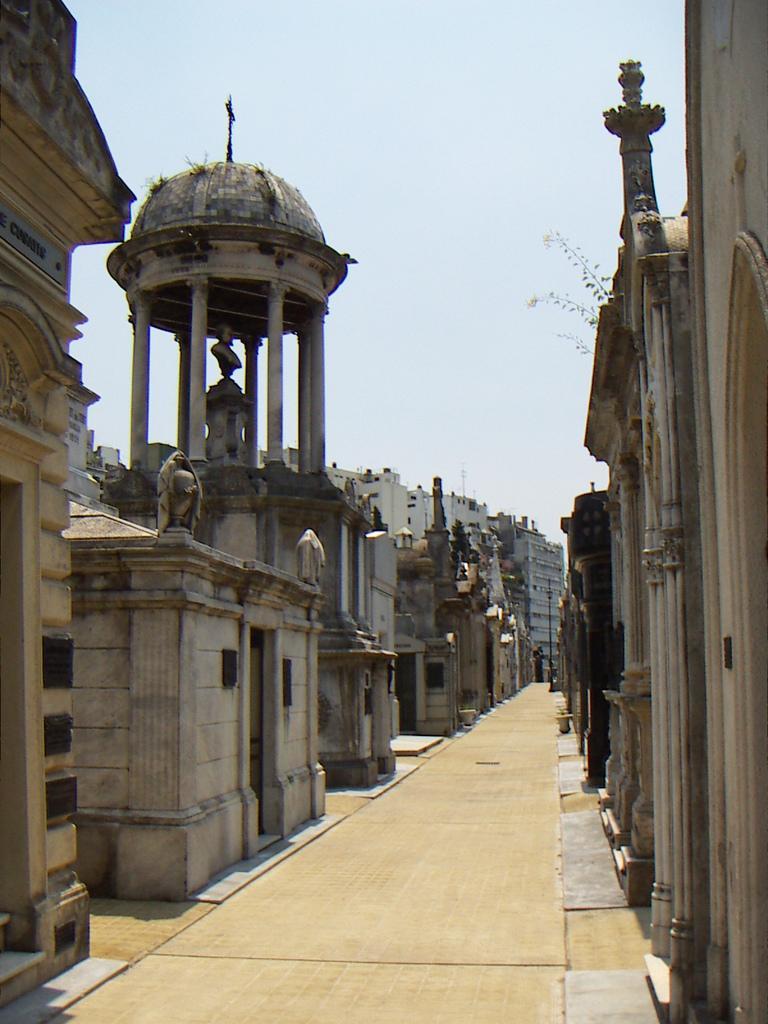Describe this image in one or two sentences. Here we can see buildings and plant. Above this statue there is a roof. Around this statue there are pillars. Background we can see the sky.  